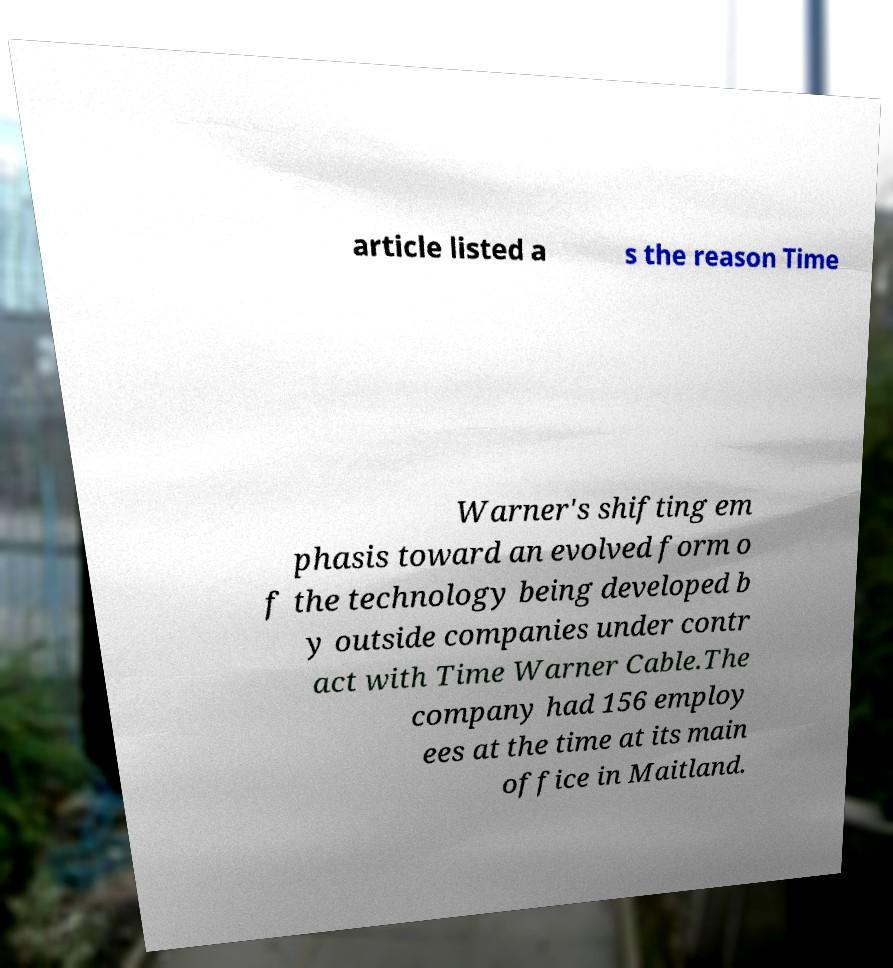Please read and relay the text visible in this image. What does it say? article listed a s the reason Time Warner's shifting em phasis toward an evolved form o f the technology being developed b y outside companies under contr act with Time Warner Cable.The company had 156 employ ees at the time at its main office in Maitland. 